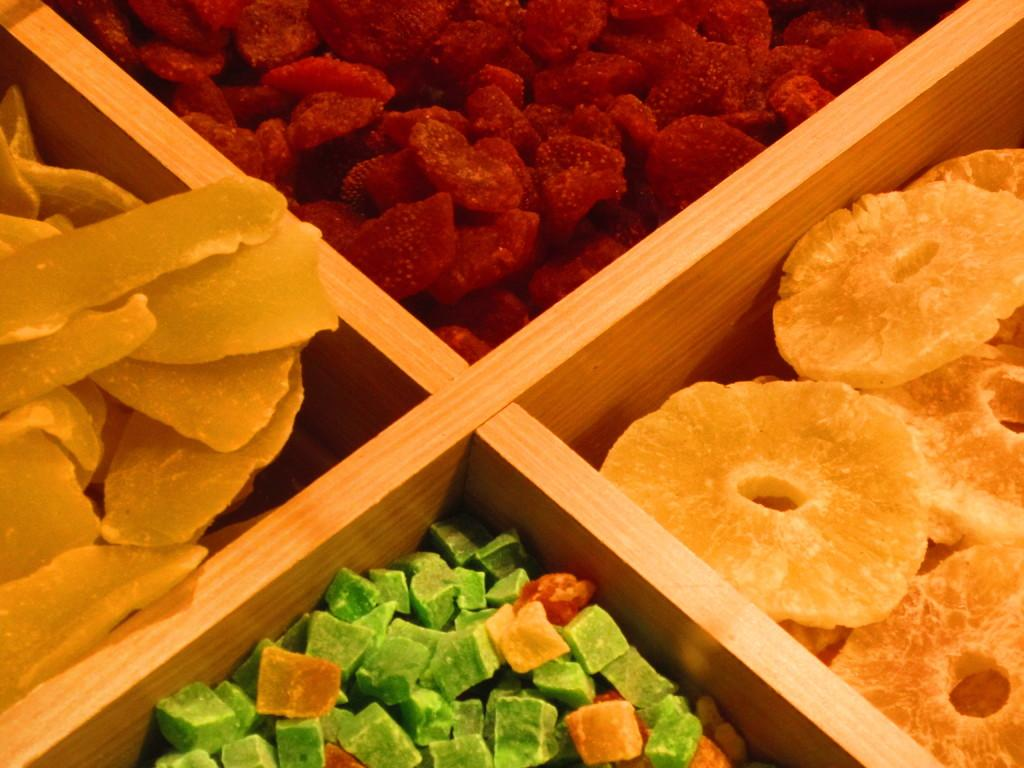What type of food is visible in the image? There are dry fruits in the image. How are the dry fruits arranged in the image? The dry fruits are arranged on shelves. What type of calculator is visible on the wall in the image? There is no calculator present in the image. Is there a boy standing near the dry fruits in the image? There is no boy present in the image. 